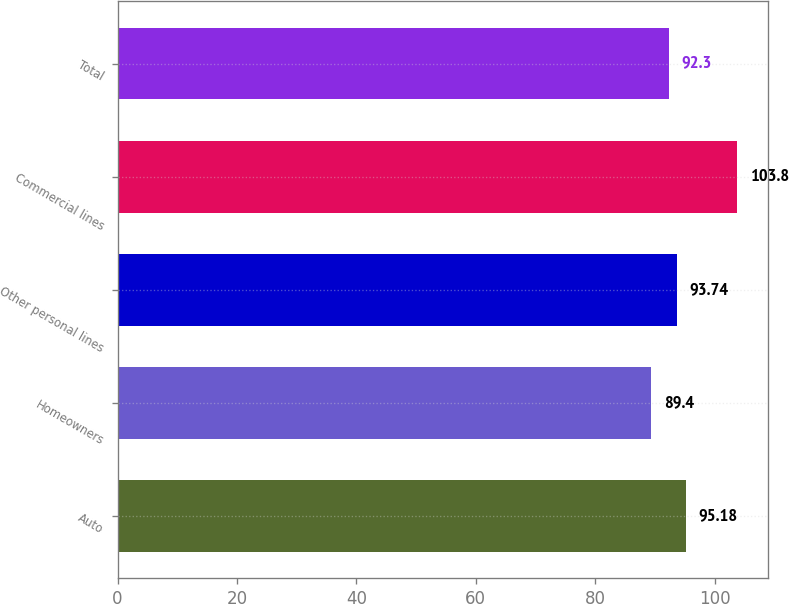Convert chart. <chart><loc_0><loc_0><loc_500><loc_500><bar_chart><fcel>Auto<fcel>Homeowners<fcel>Other personal lines<fcel>Commercial lines<fcel>Total<nl><fcel>95.18<fcel>89.4<fcel>93.74<fcel>103.8<fcel>92.3<nl></chart> 